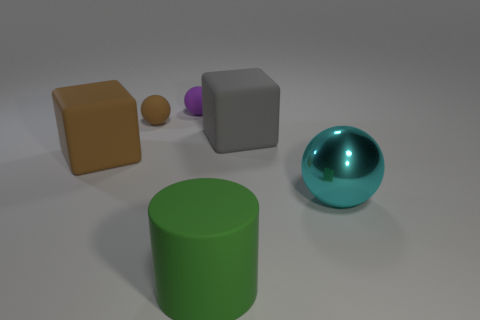Subtract all rubber balls. How many balls are left? 1 Add 2 brown rubber spheres. How many objects exist? 8 Subtract all blue balls. Subtract all gray blocks. How many balls are left? 3 Subtract all cubes. How many objects are left? 4 Subtract 0 yellow cubes. How many objects are left? 6 Subtract all small objects. Subtract all matte cylinders. How many objects are left? 3 Add 2 large brown objects. How many large brown objects are left? 3 Add 5 blue metallic cylinders. How many blue metallic cylinders exist? 5 